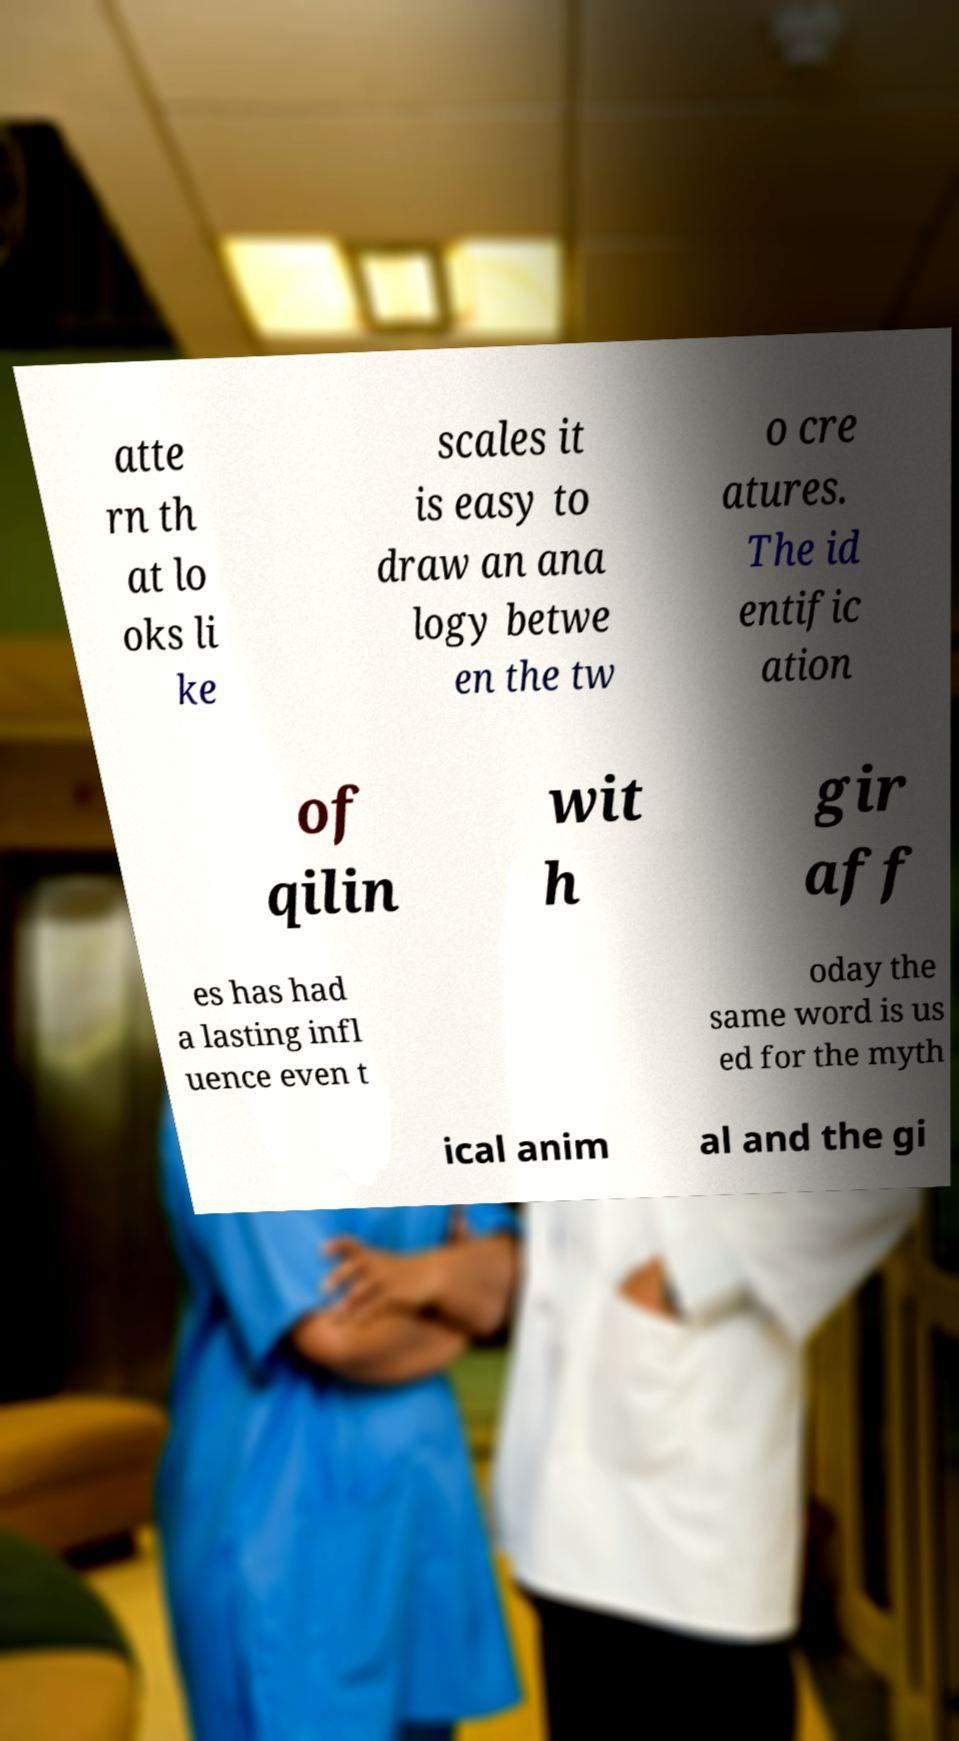What messages or text are displayed in this image? I need them in a readable, typed format. atte rn th at lo oks li ke scales it is easy to draw an ana logy betwe en the tw o cre atures. The id entific ation of qilin wit h gir aff es has had a lasting infl uence even t oday the same word is us ed for the myth ical anim al and the gi 